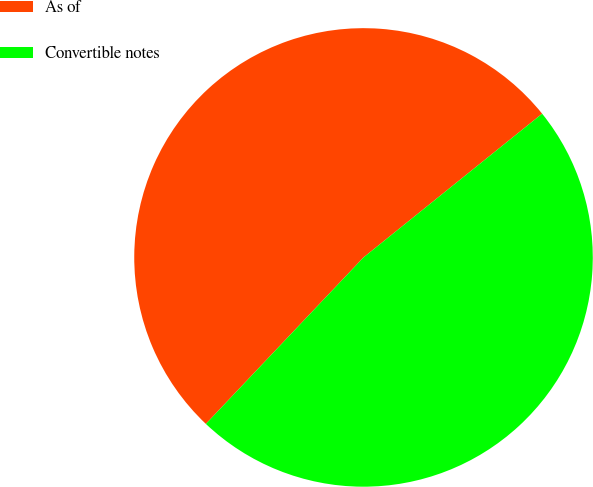Convert chart to OTSL. <chart><loc_0><loc_0><loc_500><loc_500><pie_chart><fcel>As of<fcel>Convertible notes<nl><fcel>52.15%<fcel>47.85%<nl></chart> 